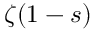<formula> <loc_0><loc_0><loc_500><loc_500>\zeta ( 1 - s )</formula> 